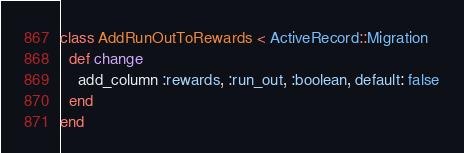Convert code to text. <code><loc_0><loc_0><loc_500><loc_500><_Ruby_>class AddRunOutToRewards < ActiveRecord::Migration
  def change
    add_column :rewards, :run_out, :boolean, default: false
  end
end
</code> 